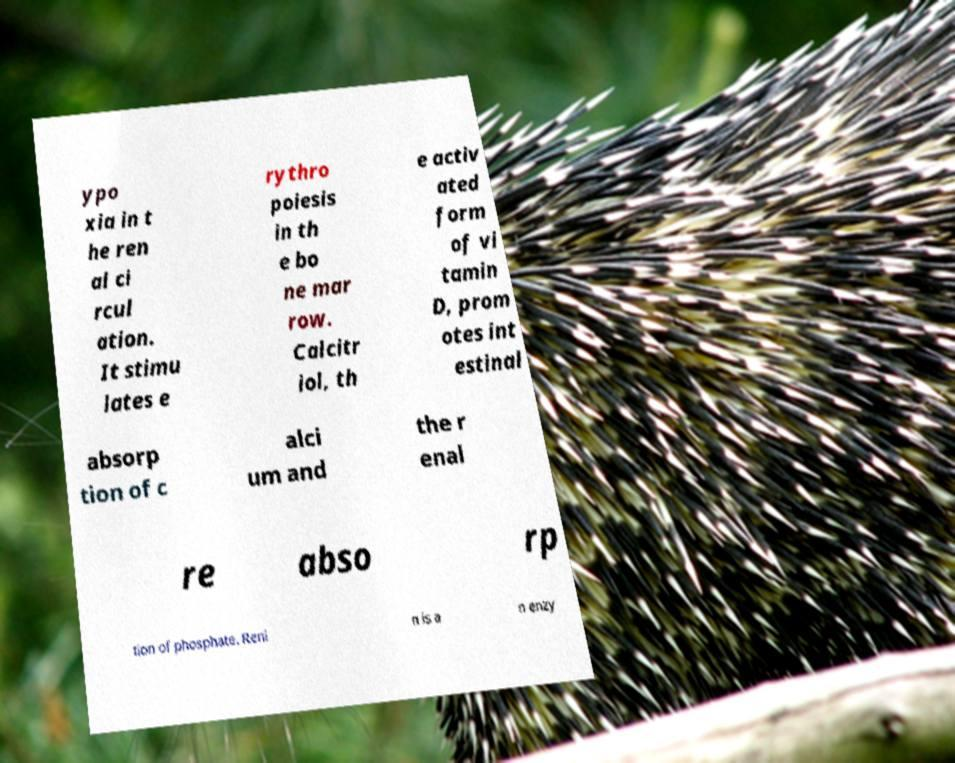Can you accurately transcribe the text from the provided image for me? ypo xia in t he ren al ci rcul ation. It stimu lates e rythro poiesis in th e bo ne mar row. Calcitr iol, th e activ ated form of vi tamin D, prom otes int estinal absorp tion of c alci um and the r enal re abso rp tion of phosphate. Reni n is a n enzy 